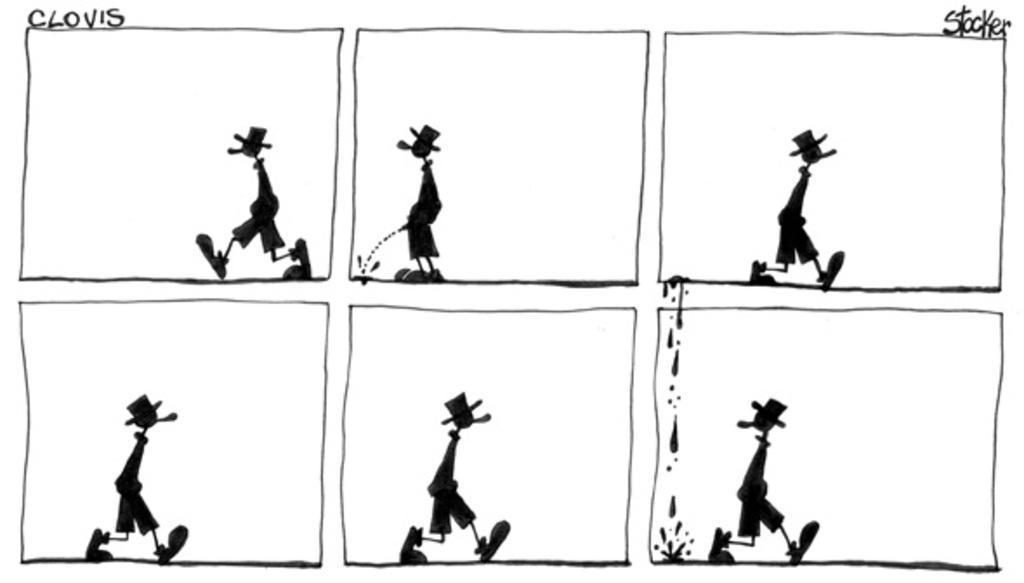In one or two sentences, can you explain what this image depicts? In the image we can see there is a collage of pictures and it is a cartoon image. There is a person standing and the image is in black and white colour. 